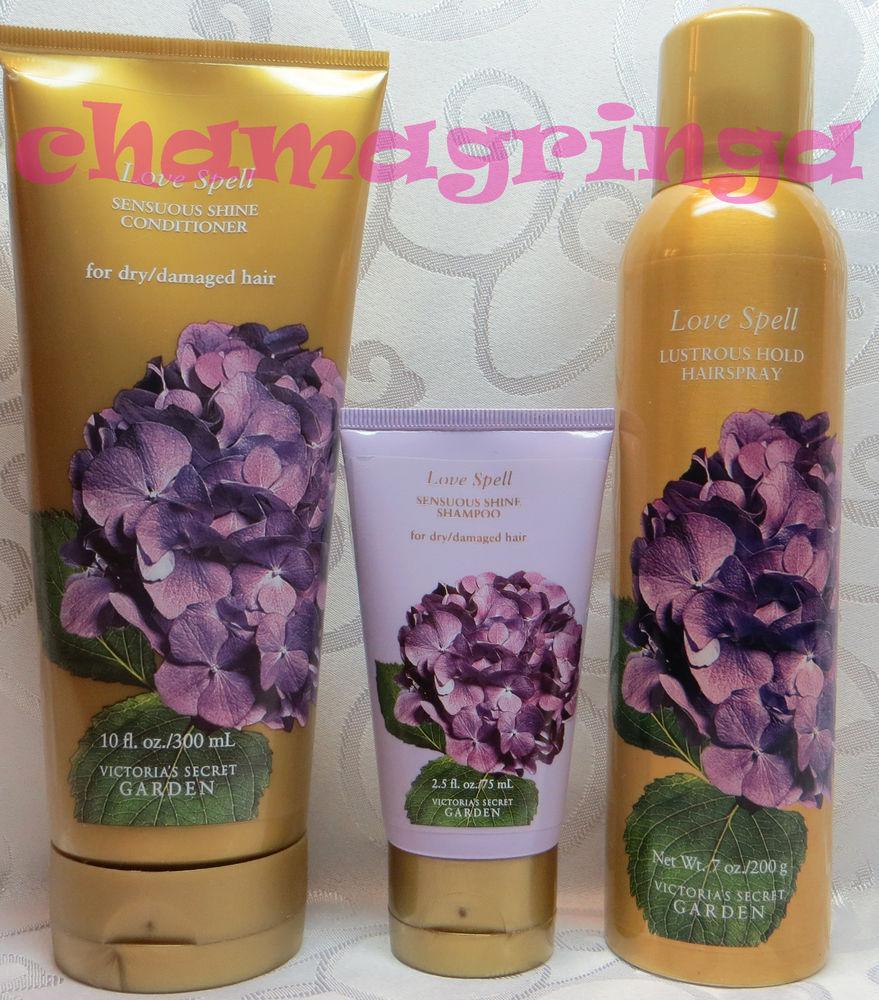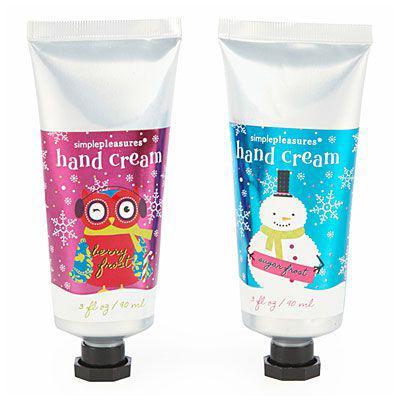The first image is the image on the left, the second image is the image on the right. For the images displayed, is the sentence "At least ten lotion-type products are shown in total." factually correct? Answer yes or no. No. The first image is the image on the left, the second image is the image on the right. Evaluate the accuracy of this statement regarding the images: "The right image shows just two skincare items side-by-side.". Is it true? Answer yes or no. Yes. 